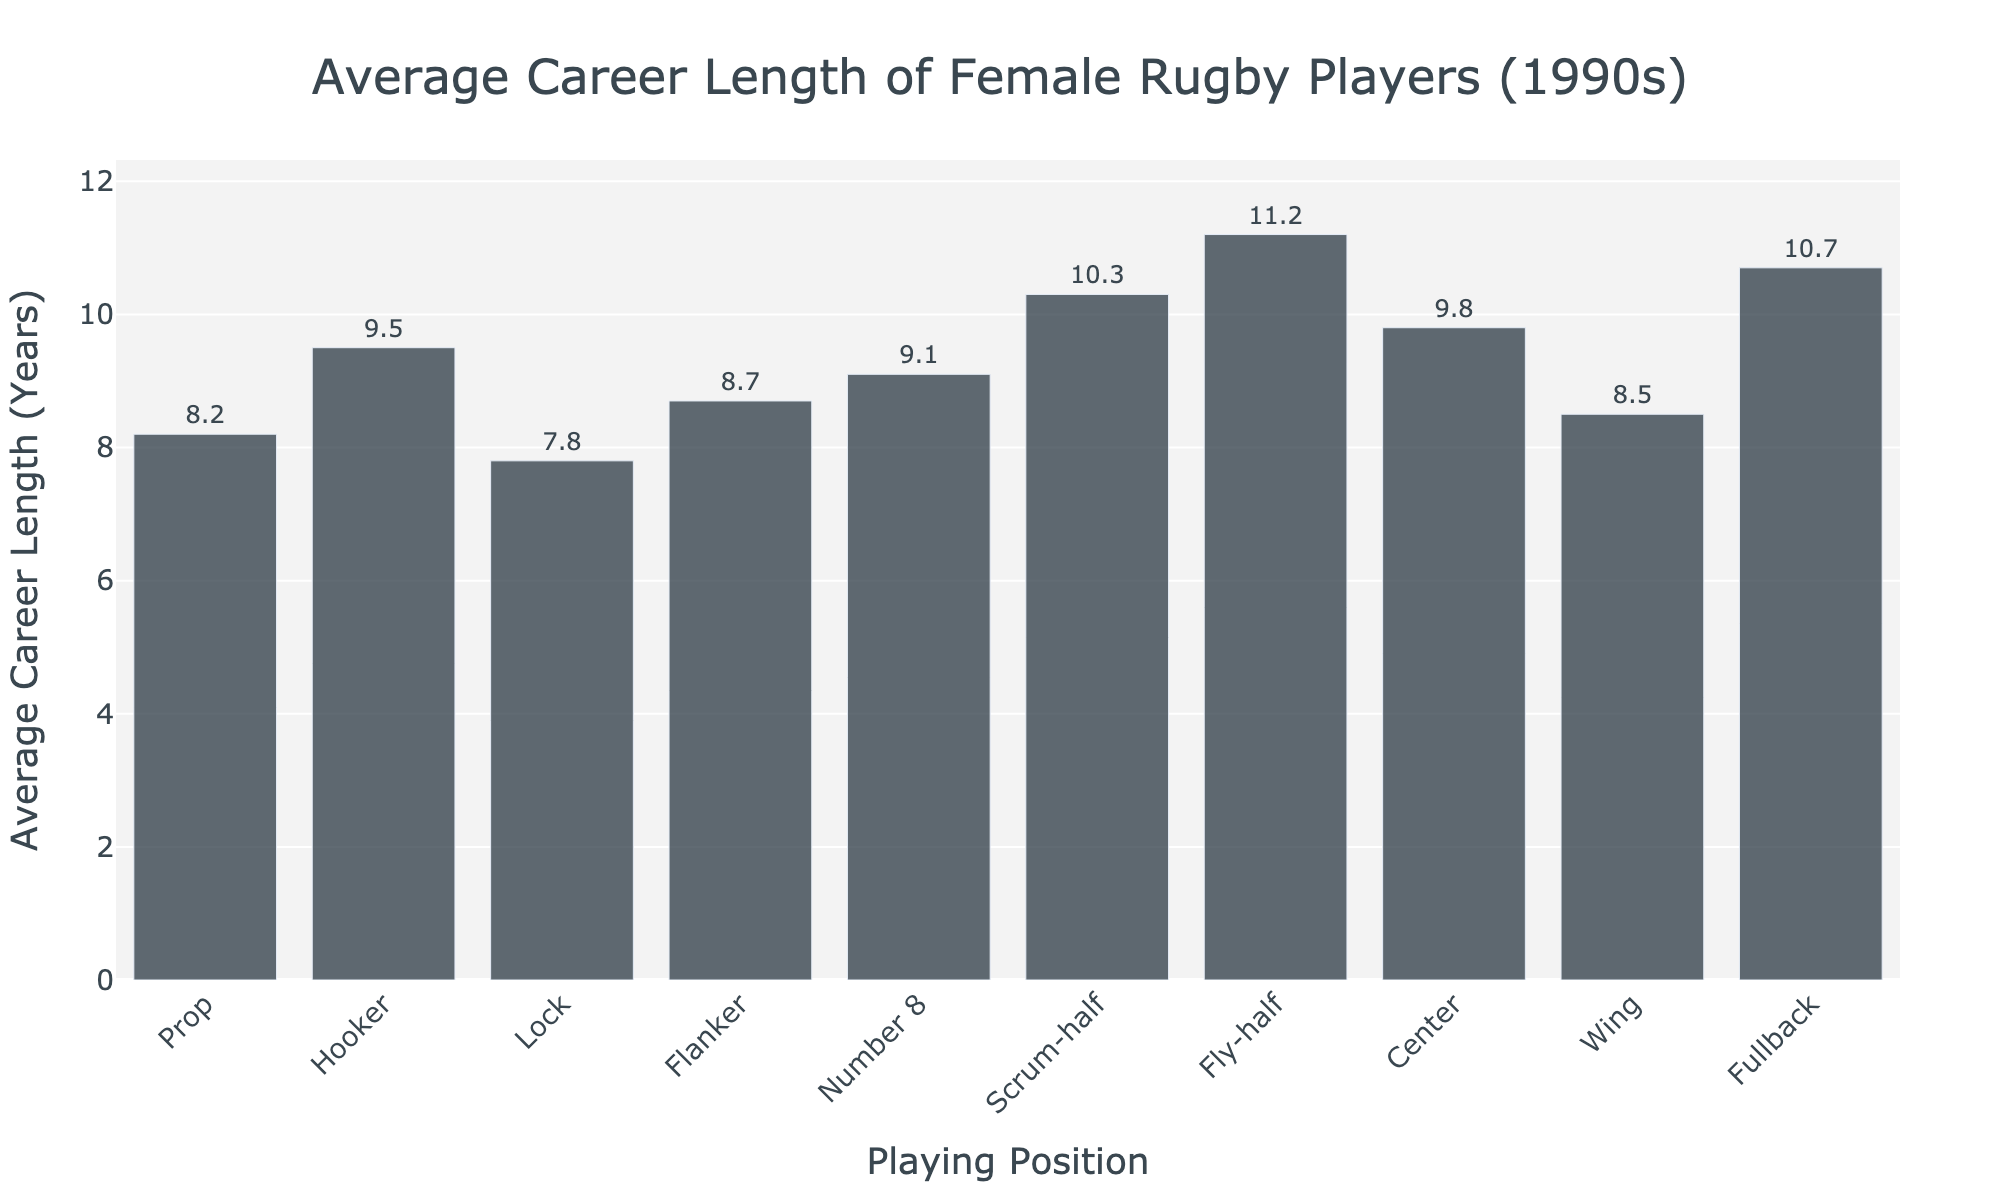What's the average career length of players in the positions of Prop, Hooker, and Lock combined? To find the average, add the average career lengths of the Prop (8.2), Hooker (9.5), and Lock (7.8) positions and divide by the number of positions (3). So, (8.2 + 9.5 + 7.8) / 3 = 25.5 / 3 = 8.5.
Answer: 8.5 Which position has the longest average career length? Look for the position with the highest average career length from the bar chart. Scrum-half has 10.3 years, Fly-half has 11.2 years, and Fullback has 10.7 years. Fly-half is the highest.
Answer: Fly-half Are there more positions with an average career length above 9 years or below 9 years? Count the number of positions above and below 9 years. Above 9: Hooker, Number 8, Scrum-half, Fly-half, Center, Fullback (6 positions). Below 9: Prop, Lock, Flanker, Wing (4 positions).
Answer: Above 9 years Which position has a shorter average career length, Lock or Wing? Compare the average career lengths of Lock (7.8 years) and Wing (8.5 years). Lock has a shorter career length.
Answer: Lock What is the difference in average career length between Fly-half and Prop? Subtract the average career length of the Prop (8.2 years) from that of Fly-half (11.2 years). 11.2 - 8.2 = 3.
Answer: 3 years Are there any positions with an average career length equal to 10 years? Check the average career length values for each position; no positions are listed with an exact 10 years average career length.
Answer: No How many positions have an average career length between 8 and 10 years? Count the positions with average career lengths in the range of 8 to 10 years: Prop (8.2), Lock (7.8 - not included), Flanker (8.7), Wing (8.5), Hooker (9.5), Number 8 (9.1) (5 positions).
Answer: 5 positions Which is the shortest average career length among the positions? Identify the position with the shortest average career length from the chart. Lock has the shortest at 7.8 years.
Answer: Lock 